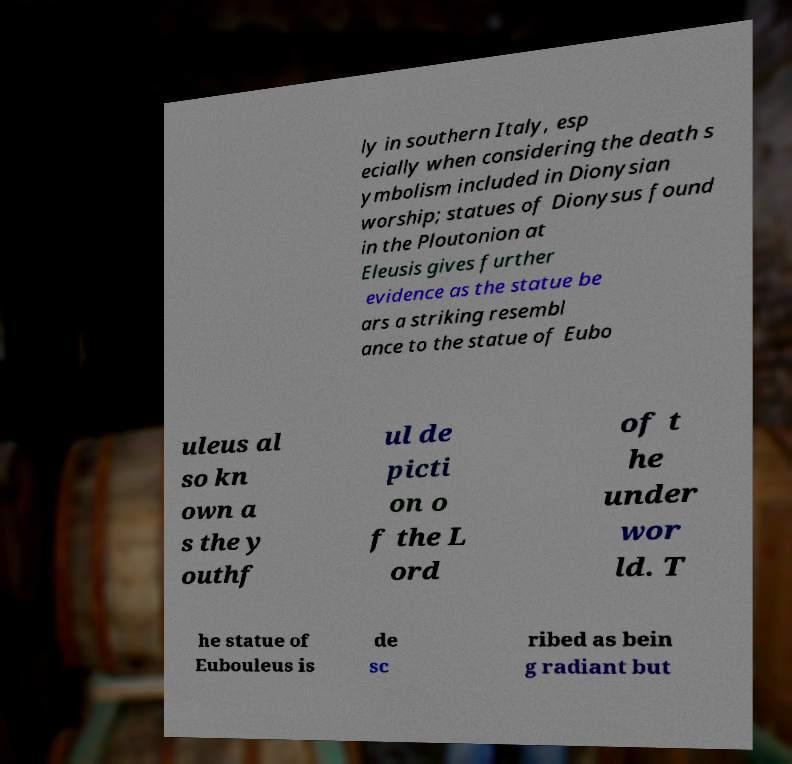There's text embedded in this image that I need extracted. Can you transcribe it verbatim? ly in southern Italy, esp ecially when considering the death s ymbolism included in Dionysian worship; statues of Dionysus found in the Ploutonion at Eleusis gives further evidence as the statue be ars a striking resembl ance to the statue of Eubo uleus al so kn own a s the y outhf ul de picti on o f the L ord of t he under wor ld. T he statue of Eubouleus is de sc ribed as bein g radiant but 